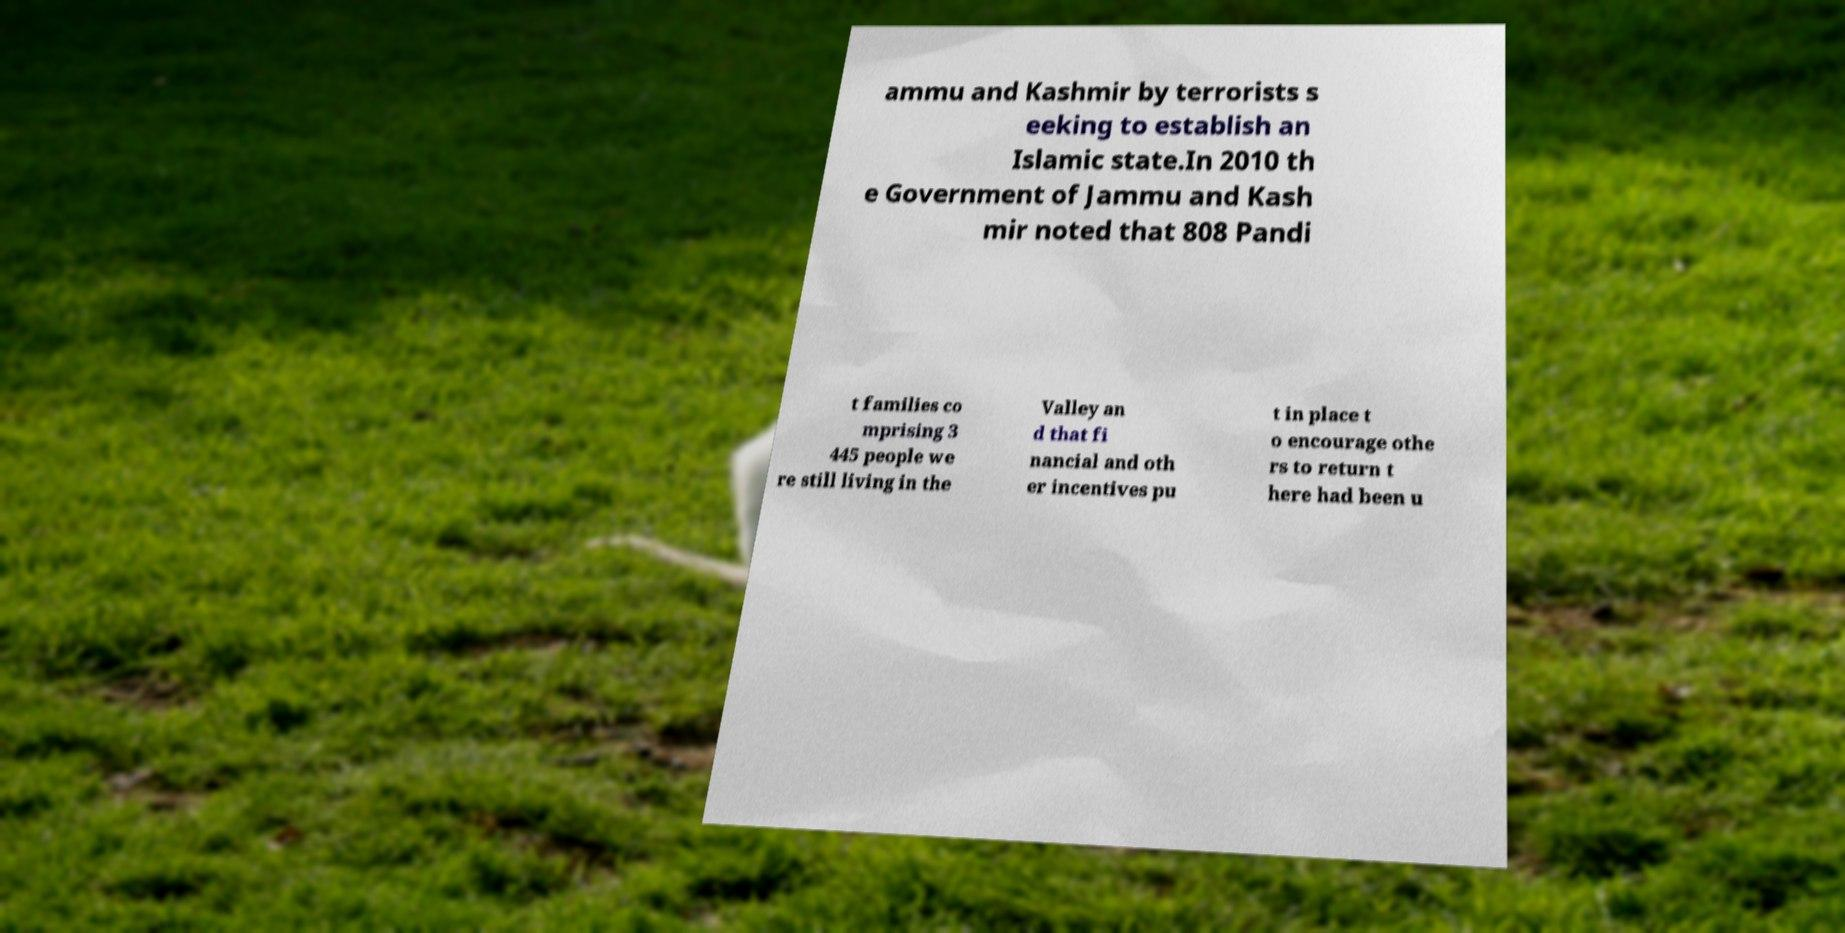Could you assist in decoding the text presented in this image and type it out clearly? ammu and Kashmir by terrorists s eeking to establish an Islamic state.In 2010 th e Government of Jammu and Kash mir noted that 808 Pandi t families co mprising 3 445 people we re still living in the Valley an d that fi nancial and oth er incentives pu t in place t o encourage othe rs to return t here had been u 